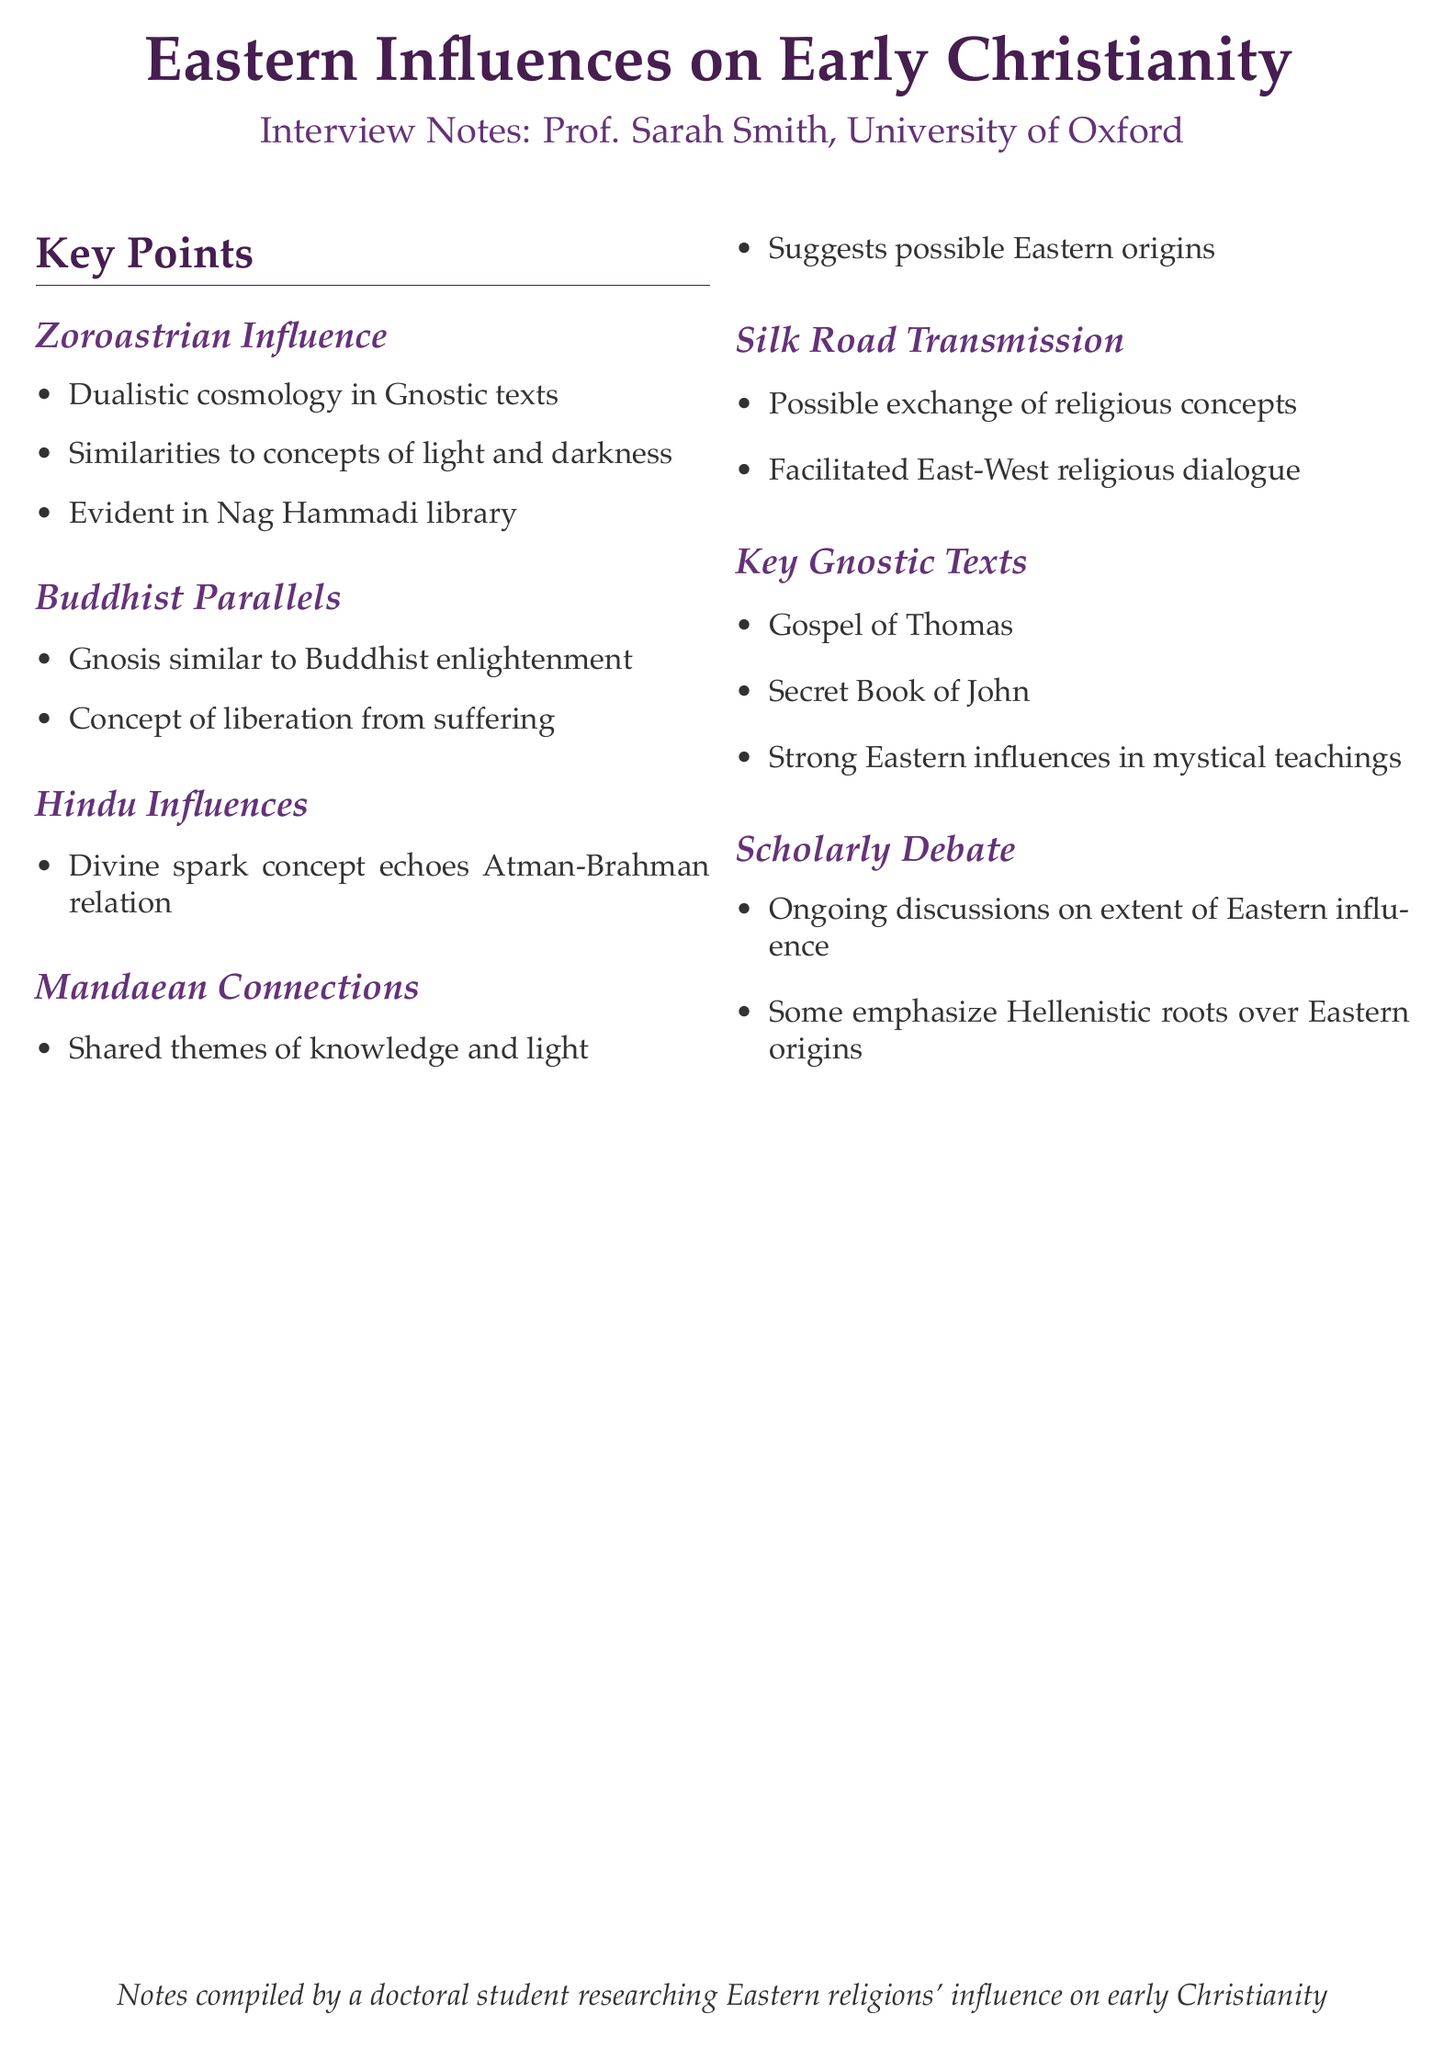What is the name of the interviewee? The interviewee is Professor Sarah Smith, who is an expert in Gnosticism and Early Christianity.
Answer: Professor Sarah Smith What concept in Gnosticism resembles Buddhist enlightenment? The concept of gnosis in Gnosticism bears resemblance to Buddhist notions of enlightenment and liberation from suffering.
Answer: Gnosis Which religious influence is associated with dualistic cosmology in Gnostic texts? Dualistic cosmology in Gnostic texts shows similarities to Zoroastrian concepts of light and darkness.
Answer: Zoroastrianism What key Gnostic text is mentioned alongside the Gospel of Thomas? The Secret Book of John is mentioned as showing strong Eastern influences in mystical teachings.
Answer: Secret Book of John What hypothesis does Professor Smith make regarding the transmission of Gnostic ideas? Professor Smith hypothesizes that Gnostic ideas may have been transmitted along the Silk Road, facilitating exchange between Eastern and Western religious concepts.
Answer: Silk Road transmission Which Eastern religion emphasizes knowledge and shares common themes with Gnostic texts? The Mandaean religion shares common themes with Gnostic texts, suggesting possible Eastern origins or influences.
Answer: Mandaean religion What ongoing academic discussion is mentioned in the notes? There are ongoing discussions about the extent of Eastern influences on Gnosticism, with some scholars emphasizing Hellenistic roots over Eastern origins.
Answer: Scholarly debate What is the overarching topic of the interview? The overarching topic of the interview is the influence of Eastern religions on early Christianity, particularly through Gnostic texts.
Answer: Eastern Influences on Early Christianity 